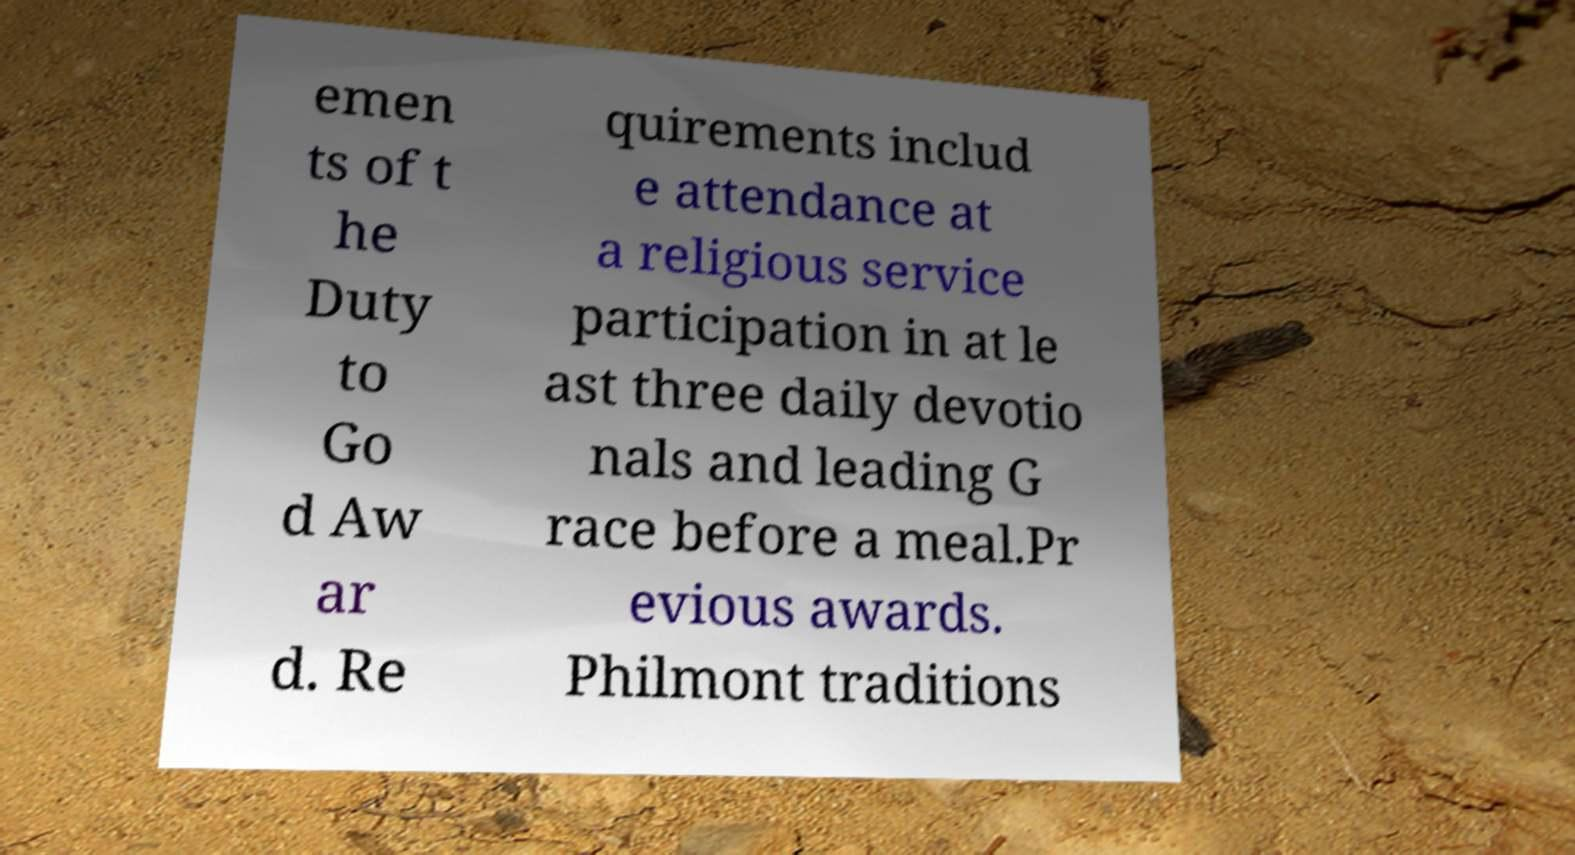Please read and relay the text visible in this image. What does it say? emen ts of t he Duty to Go d Aw ar d. Re quirements includ e attendance at a religious service participation in at le ast three daily devotio nals and leading G race before a meal.Pr evious awards. Philmont traditions 